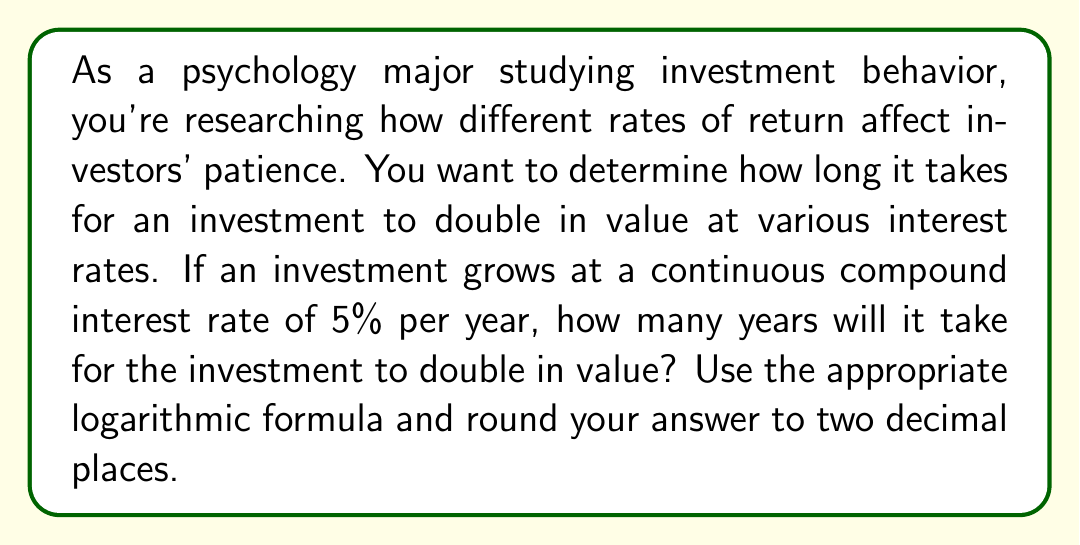What is the answer to this math problem? To solve this problem, we'll use the continuous compound interest formula and the properties of logarithms. Here's the step-by-step solution:

1) The formula for continuous compound interest is:
   $$A = P e^{rt}$$
   where A is the final amount, P is the principal (initial investment), r is the interest rate, and t is the time in years.

2) We want to find when the investment doubles, so A = 2P. Substituting this into our formula:
   $$2P = P e^{rt}$$

3) Divide both sides by P:
   $$2 = e^{rt}$$

4) Take the natural logarithm of both sides:
   $$\ln(2) = \ln(e^{rt})$$

5) Using the logarithm property $\ln(e^x) = x$, we get:
   $$\ln(2) = rt$$

6) Solve for t:
   $$t = \frac{\ln(2)}{r}$$

7) Now, substitute r = 0.05 (5% as a decimal):
   $$t = \frac{\ln(2)}{0.05}$$

8) Calculate:
   $$t = \frac{0.693147...}{0.05} = 13.8629...$$

9) Rounding to two decimal places:
   $$t \approx 13.86 \text{ years}$$

This solution demonstrates the use of logarithms to solve financial problems, which is relevant to understanding investor behavior and decision-making in psychology studies.
Answer: 13.86 years 